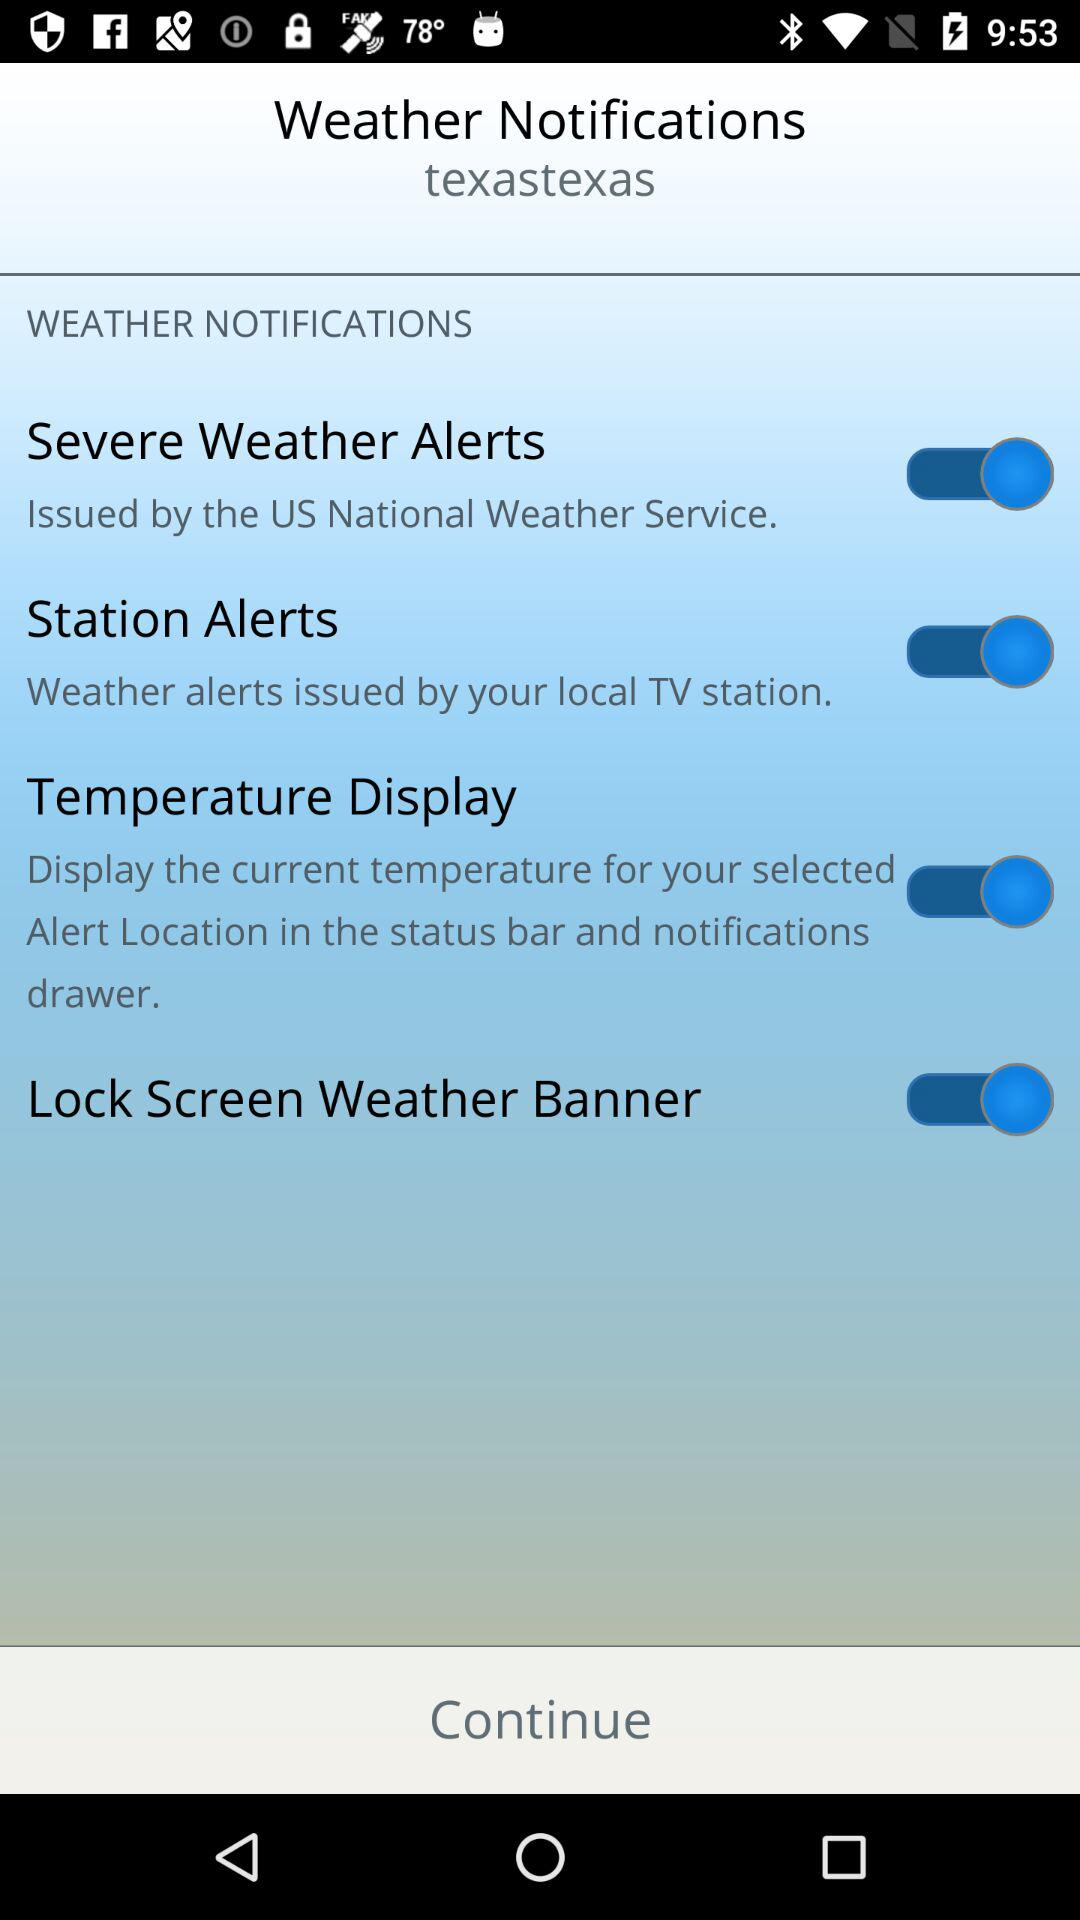How many types of alerts can be turned on?
Answer the question using a single word or phrase. 3 